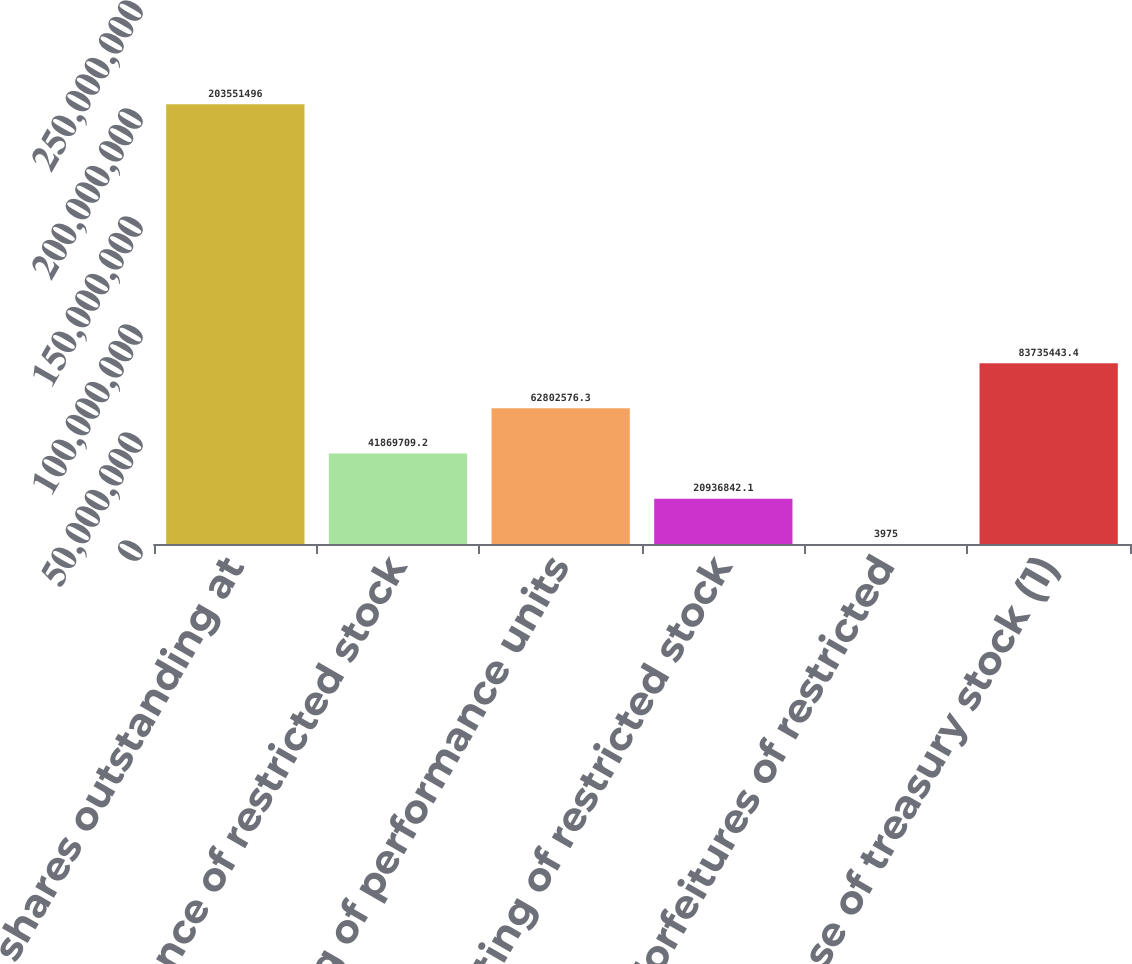<chart> <loc_0><loc_0><loc_500><loc_500><bar_chart><fcel>Common shares outstanding at<fcel>Issuance of restricted stock<fcel>Vesting of performance units<fcel>Vesting of restricted stock<fcel>Forfeitures of restricted<fcel>Purchase of treasury stock (1)<nl><fcel>2.03551e+08<fcel>4.18697e+07<fcel>6.28026e+07<fcel>2.09368e+07<fcel>3975<fcel>8.37354e+07<nl></chart> 